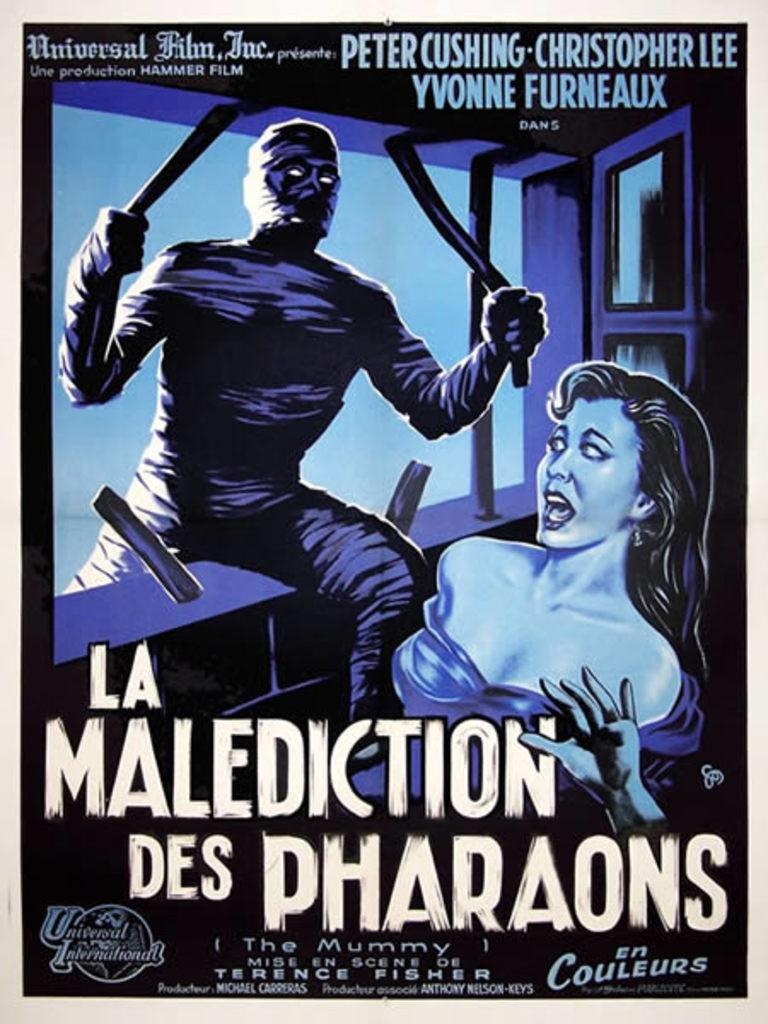<image>
Provide a brief description of the given image. A poster of an advertisement for The Mummy 